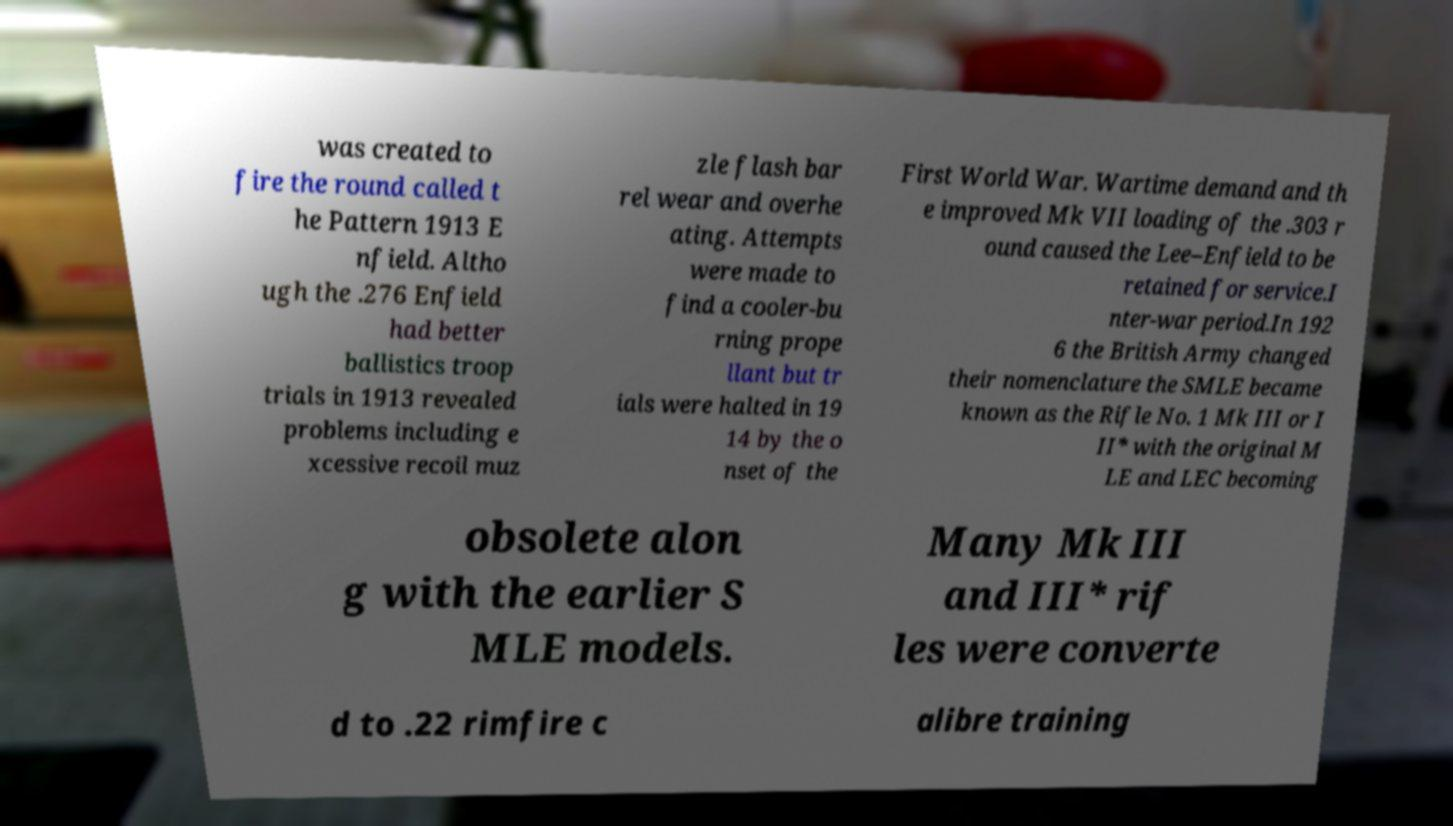Can you accurately transcribe the text from the provided image for me? was created to fire the round called t he Pattern 1913 E nfield. Altho ugh the .276 Enfield had better ballistics troop trials in 1913 revealed problems including e xcessive recoil muz zle flash bar rel wear and overhe ating. Attempts were made to find a cooler-bu rning prope llant but tr ials were halted in 19 14 by the o nset of the First World War. Wartime demand and th e improved Mk VII loading of the .303 r ound caused the Lee–Enfield to be retained for service.I nter-war period.In 192 6 the British Army changed their nomenclature the SMLE became known as the Rifle No. 1 Mk III or I II* with the original M LE and LEC becoming obsolete alon g with the earlier S MLE models. Many Mk III and III* rif les were converte d to .22 rimfire c alibre training 